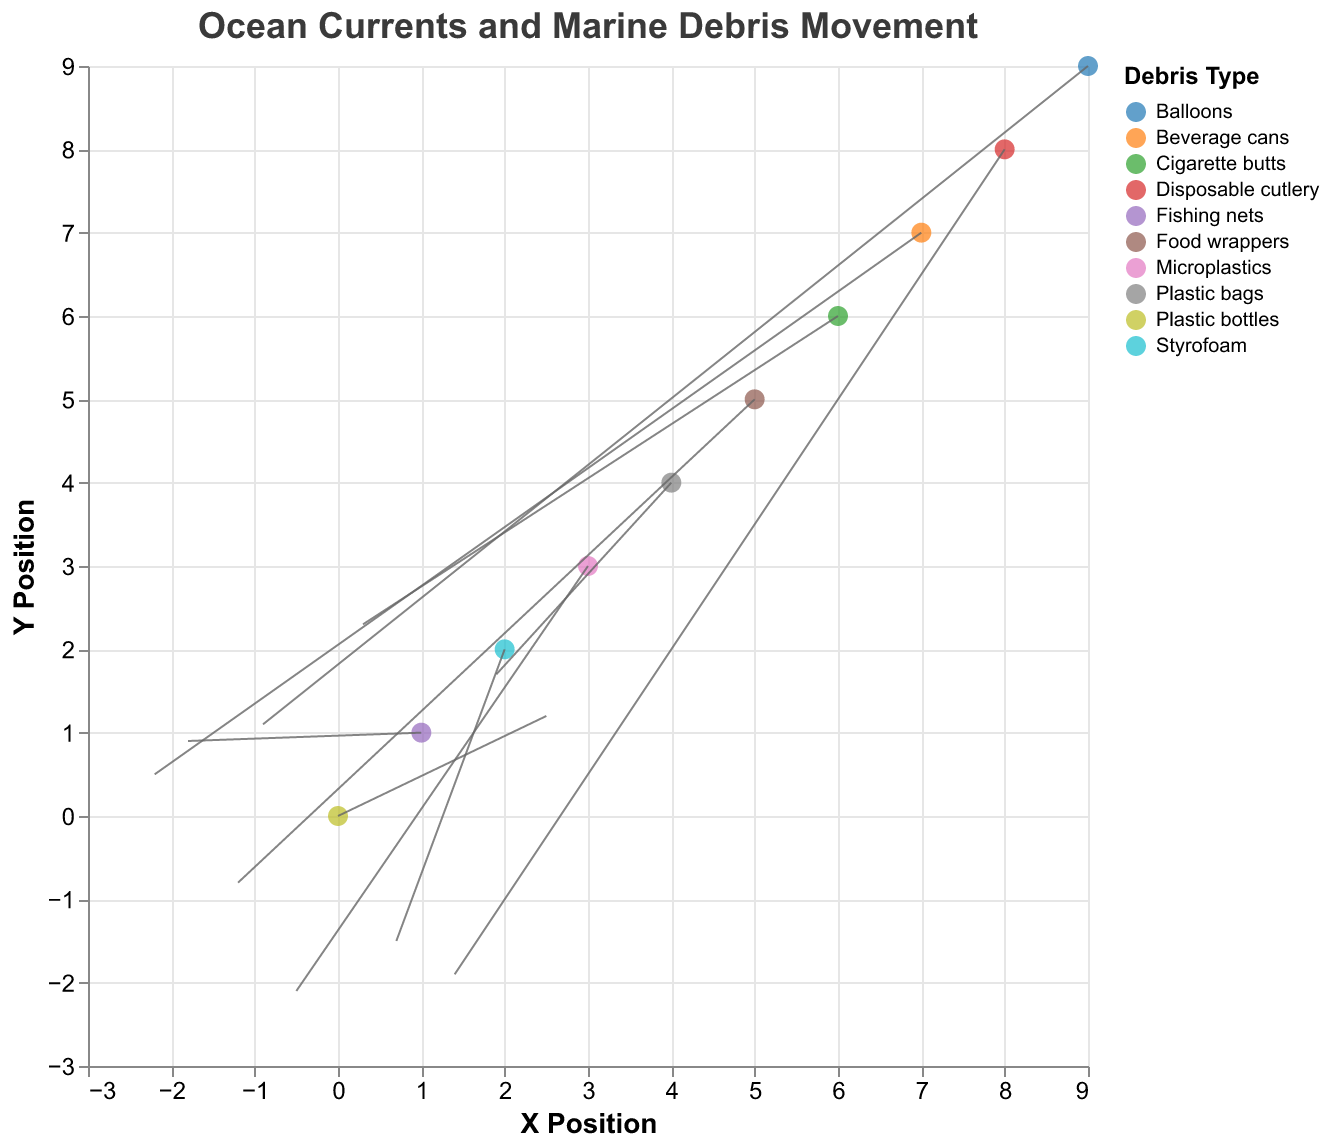What is the title of the figure? The title of the figure is displayed at the top and reads "Ocean Currents and Marine Debris Movement".
Answer: Ocean Currents and Marine Debris Movement What are the axis titles? The x-axis is titled "X Position" and the y-axis is titled "Y Position".
Answer: X Position and Y Position How many beach locations are displayed in the figure? Each point represents a beach location, and there are 10 points in the figure.
Answer: 10 Which debris type is associated with Bondi Beach? By looking at the tooltip or the legend and locating Bondi Beach, you can see that "Plastic bottles" are associated with it.
Answer: Plastic bottles What is the direction and magnitude of the current at Coogee Beach? Coogee Beach has coordinates (2, 2) with a vector (0.7, -1.5). The magnitude can be calculated using the formula √(u^2 + v^2) = √(0.7^2 + (-1.5)^2) ≈ 1.66.
Answer: Direction: (0.7, -1.5); Magnitude: ~1.66 Which beach has the highest u-component of the ocean current? Cronulla Beach has the highest u-component, which is 1.9.
Answer: Cronulla Beach Compare the ocean current vectors at Maroubra Beach and Freshwater Beach. Which beach has a stronger current? Maroubra Beach has a vector (-1.2, -0.8) and Freshwater Beach has a vector (-2.2, 0.5). Calculate the magnitudes: Maroubra Beach ≈ 1.44, Freshwater Beach ≈ 2.26. Freshwater Beach has a stronger current.
Answer: Freshwater Beach Which debris type is most likely to move towards the north-east direction? Currents moving towards the north-east have positive u and v components. Cigarette butts at Dee Why Beach have a vector (0.3, 2.3).
Answer: Cigarette butts What is the average x-component of the ocean current across all beaches? Sum of u-components: 2.5 - 1.8 + 0.7 - 0.5 + 1.9 - 1.2 + 0.3 - 2.2 + 1.4 - 0.9 = 0.2. Average: 0.2 / 10 = 0.02.
Answer: 0.02 